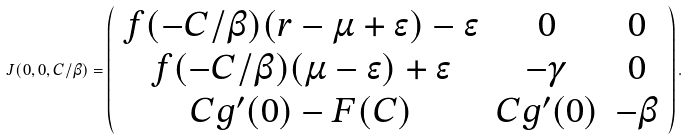<formula> <loc_0><loc_0><loc_500><loc_500>J ( 0 , 0 , C / \beta ) = \left ( \begin{array} { c c c } f ( - C / \beta ) ( r - \mu + \epsilon ) - \epsilon & 0 & 0 \\ f ( - C / \beta ) ( \mu - \epsilon ) + \epsilon & - \gamma & 0 \\ C g ^ { \prime } ( 0 ) - F ( C ) & C g ^ { \prime } ( 0 ) & - \beta \\ \end{array} \right ) .</formula> 